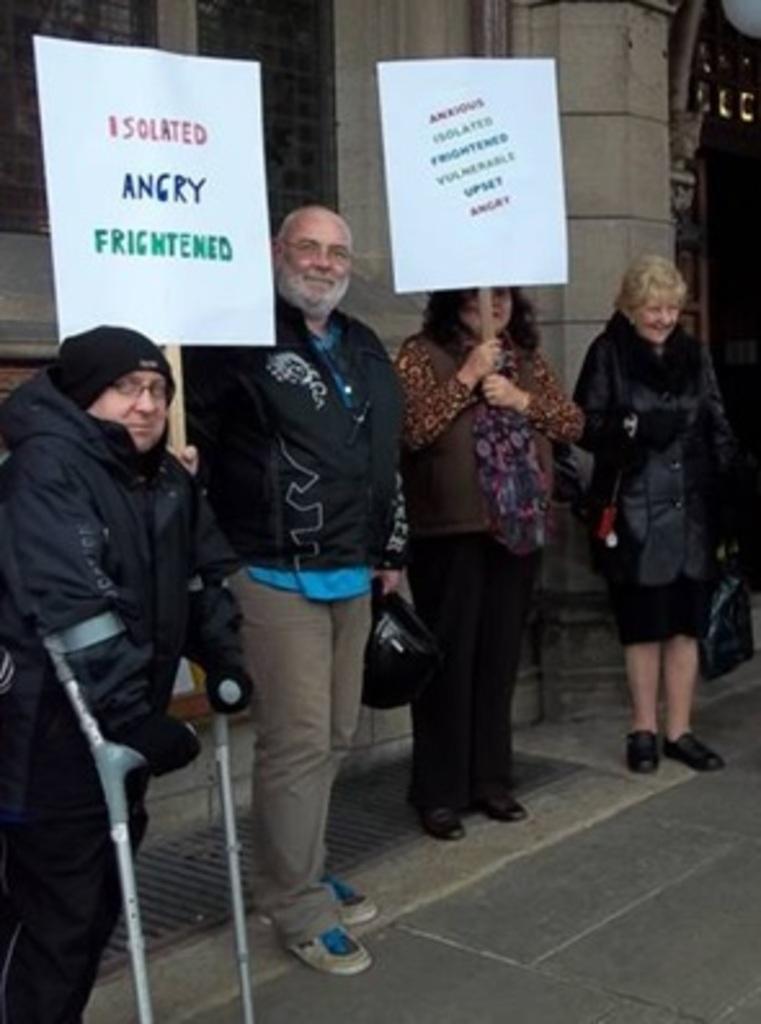Can you describe this image briefly? In the image there is are few people with sweat shirt standing on side of road in front of wall holding banners with slogans on it. 